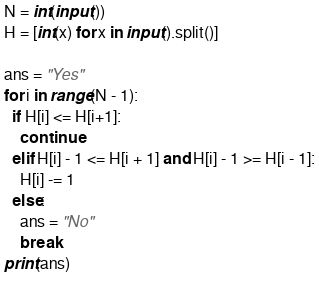<code> <loc_0><loc_0><loc_500><loc_500><_Python_>N = int(input())
H = [int(x) for x in input().split()]

ans = "Yes"
for i in range(N - 1):
  if H[i] <= H[i+1]:
    continue
  elif H[i] - 1 <= H[i + 1] and H[i] - 1 >= H[i - 1]:
    H[i] -= 1
  else:
    ans = "No"
    break
print(ans)</code> 